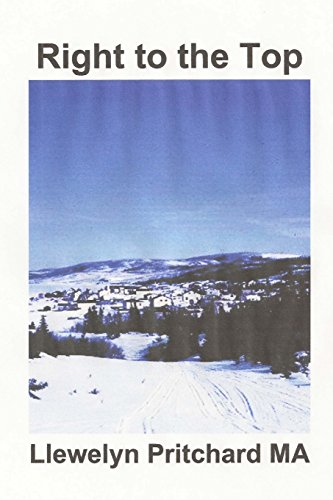Is this book related to Humor & Entertainment? No, this book is not categorised within 'Humor & Entertainment'. It seems to focus more on mystery and intrigue, particularly appealing to a younger audience. 